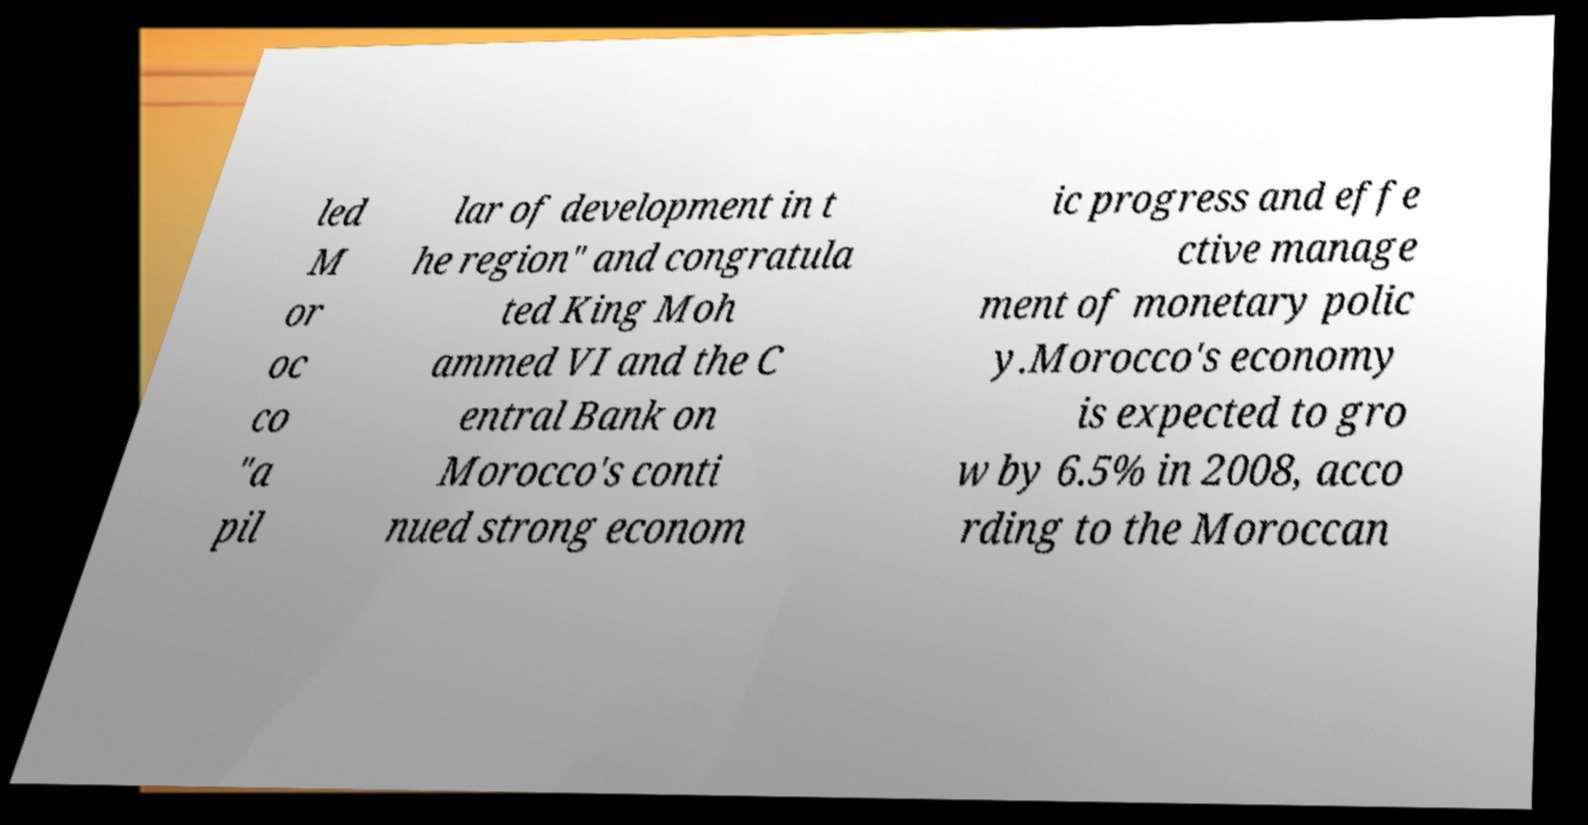For documentation purposes, I need the text within this image transcribed. Could you provide that? led M or oc co "a pil lar of development in t he region" and congratula ted King Moh ammed VI and the C entral Bank on Morocco's conti nued strong econom ic progress and effe ctive manage ment of monetary polic y.Morocco's economy is expected to gro w by 6.5% in 2008, acco rding to the Moroccan 